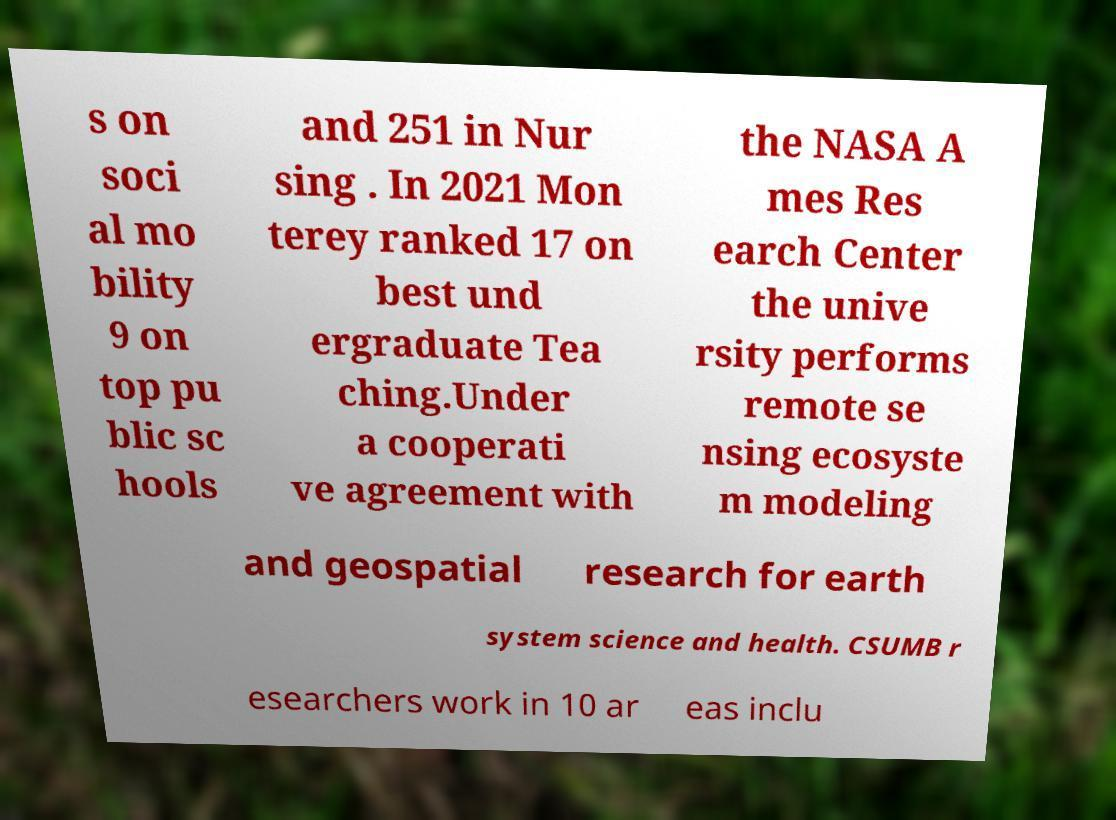Please read and relay the text visible in this image. What does it say? s on soci al mo bility 9 on top pu blic sc hools and 251 in Nur sing . In 2021 Mon terey ranked 17 on best und ergraduate Tea ching.Under a cooperati ve agreement with the NASA A mes Res earch Center the unive rsity performs remote se nsing ecosyste m modeling and geospatial research for earth system science and health. CSUMB r esearchers work in 10 ar eas inclu 